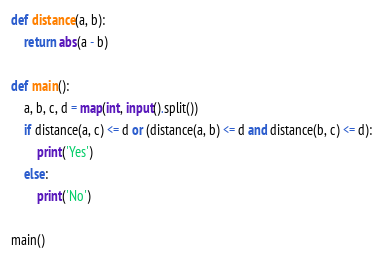Convert code to text. <code><loc_0><loc_0><loc_500><loc_500><_Python_>def distance(a, b):
    return abs(a - b)

def main():
    a, b, c, d = map(int, input().split())
    if distance(a, c) <= d or (distance(a, b) <= d and distance(b, c) <= d):
        print('Yes')
    else:
        print('No')

main()</code> 